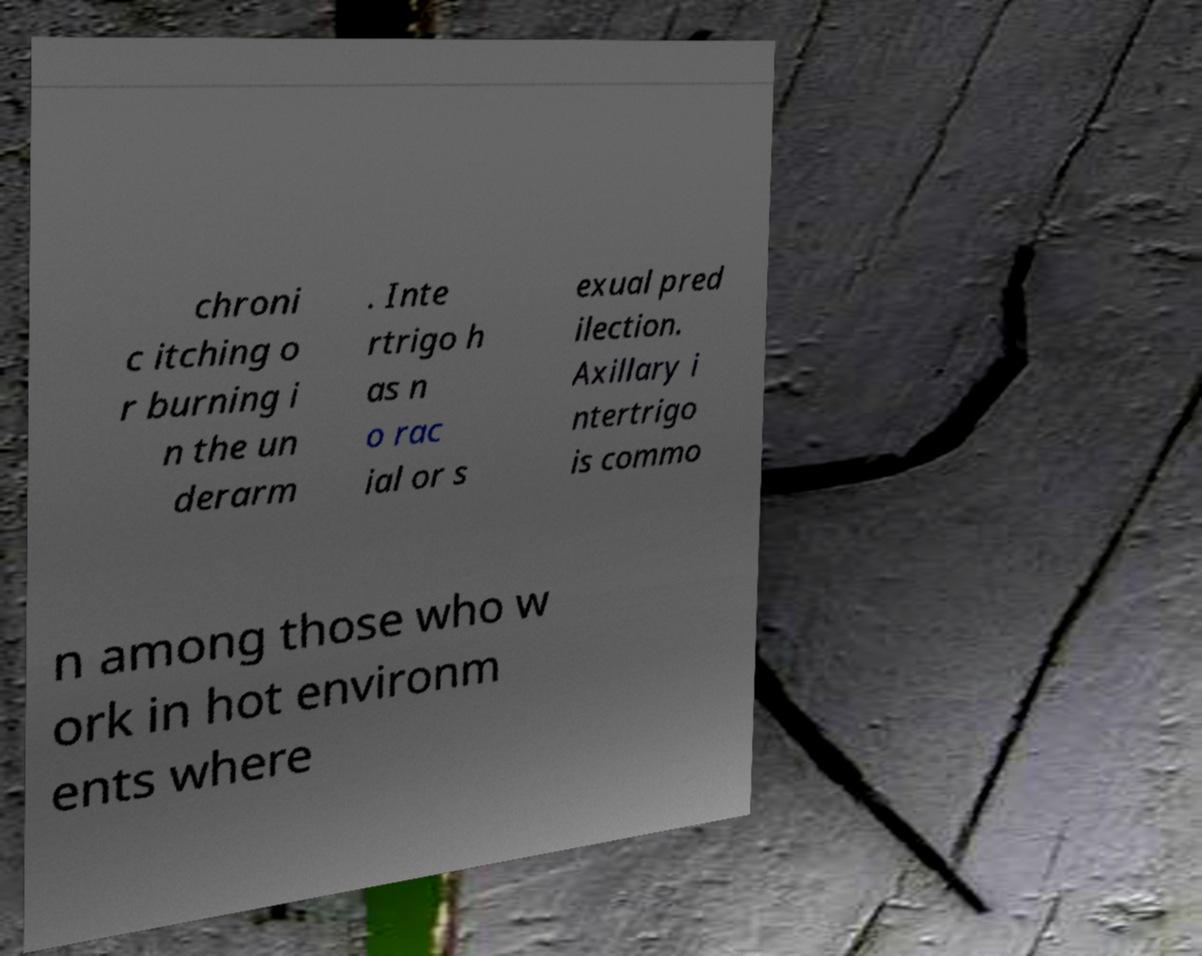For documentation purposes, I need the text within this image transcribed. Could you provide that? chroni c itching o r burning i n the un derarm . Inte rtrigo h as n o rac ial or s exual pred ilection. Axillary i ntertrigo is commo n among those who w ork in hot environm ents where 